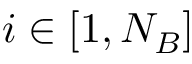<formula> <loc_0><loc_0><loc_500><loc_500>i \in [ 1 , N _ { B } ]</formula> 